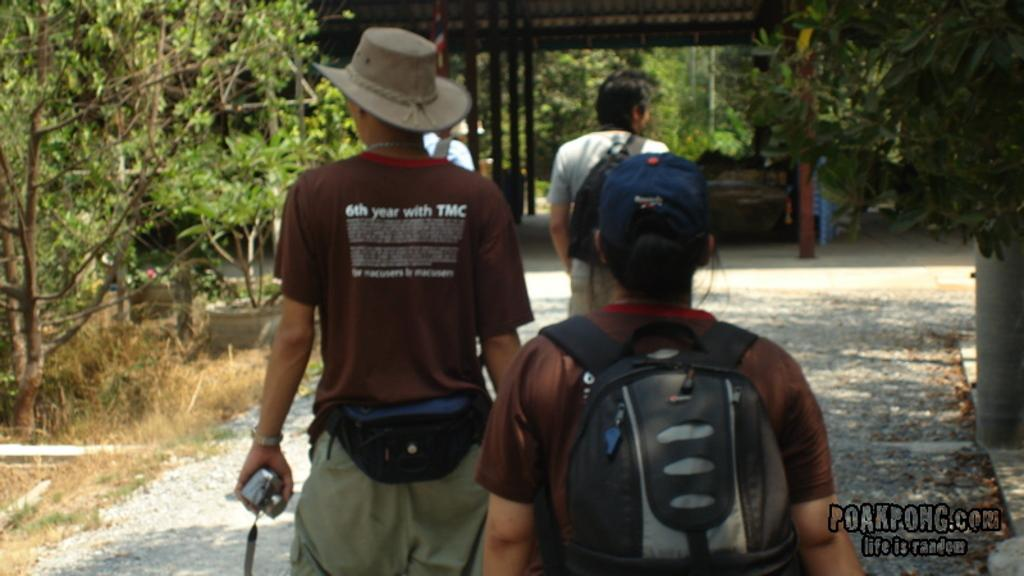<image>
Summarize the visual content of the image. people walking in a park and one wears a shirt that says "6th year with TMC" 